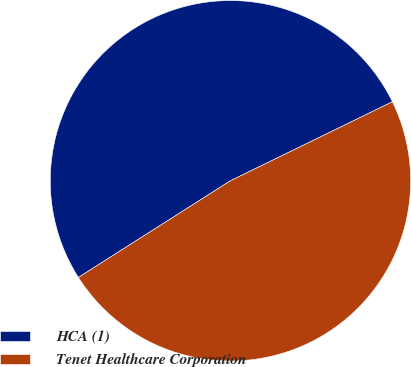<chart> <loc_0><loc_0><loc_500><loc_500><pie_chart><fcel>HCA (1)<fcel>Tenet Healthcare Corporation<nl><fcel>51.79%<fcel>48.21%<nl></chart> 